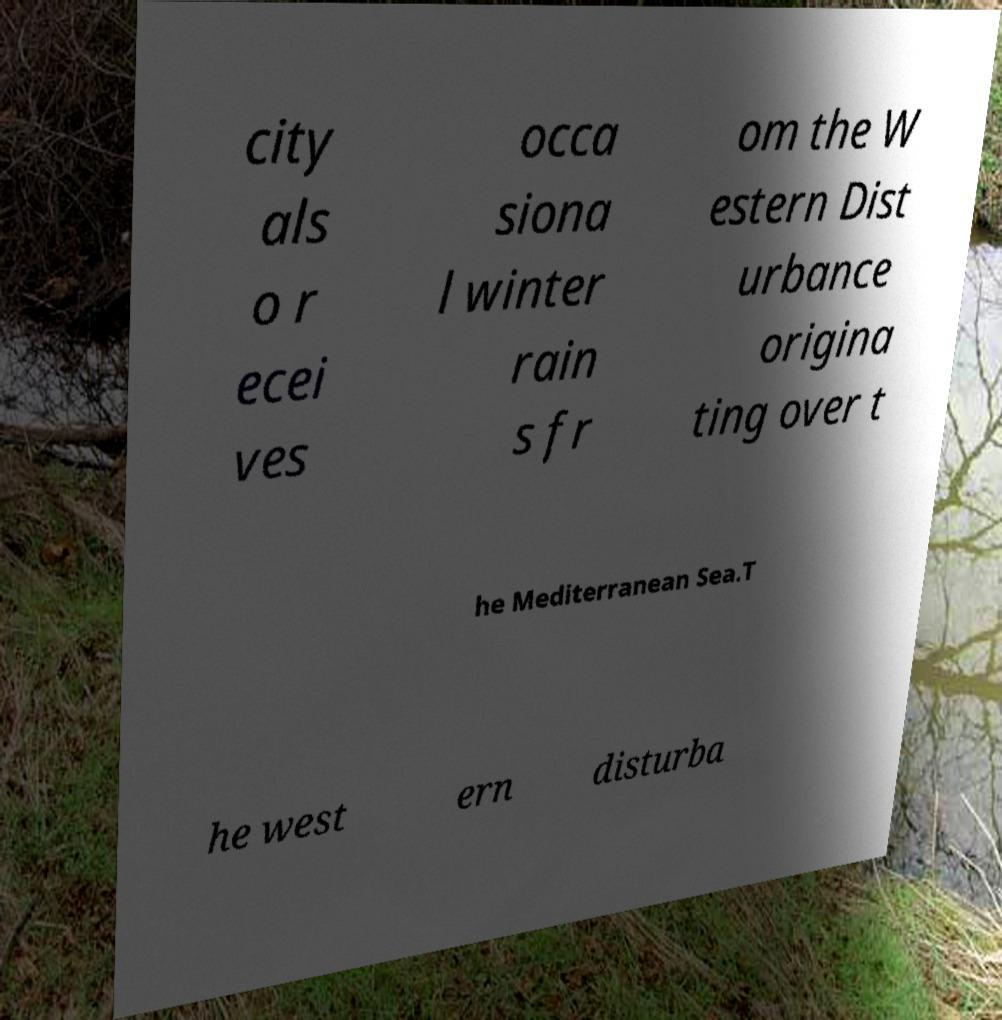For documentation purposes, I need the text within this image transcribed. Could you provide that? city als o r ecei ves occa siona l winter rain s fr om the W estern Dist urbance origina ting over t he Mediterranean Sea.T he west ern disturba 